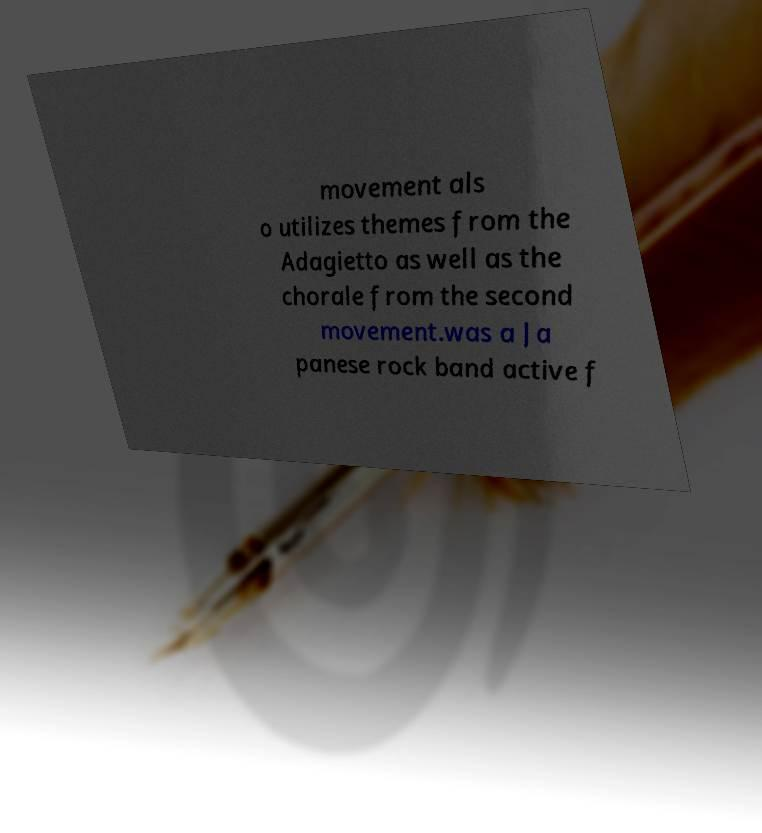Please identify and transcribe the text found in this image. movement als o utilizes themes from the Adagietto as well as the chorale from the second movement.was a Ja panese rock band active f 